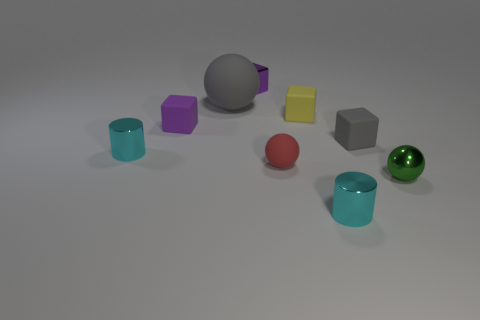Add 1 large brown cylinders. How many objects exist? 10 Subtract all cylinders. How many objects are left? 7 Add 4 small rubber spheres. How many small rubber spheres are left? 5 Add 6 brown shiny cylinders. How many brown shiny cylinders exist? 6 Subtract 0 red cylinders. How many objects are left? 9 Subtract all small objects. Subtract all small purple rubber blocks. How many objects are left? 0 